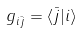<formula> <loc_0><loc_0><loc_500><loc_500>g _ { i { \bar { j } } } = \langle { \bar { j } } | i \rangle</formula> 